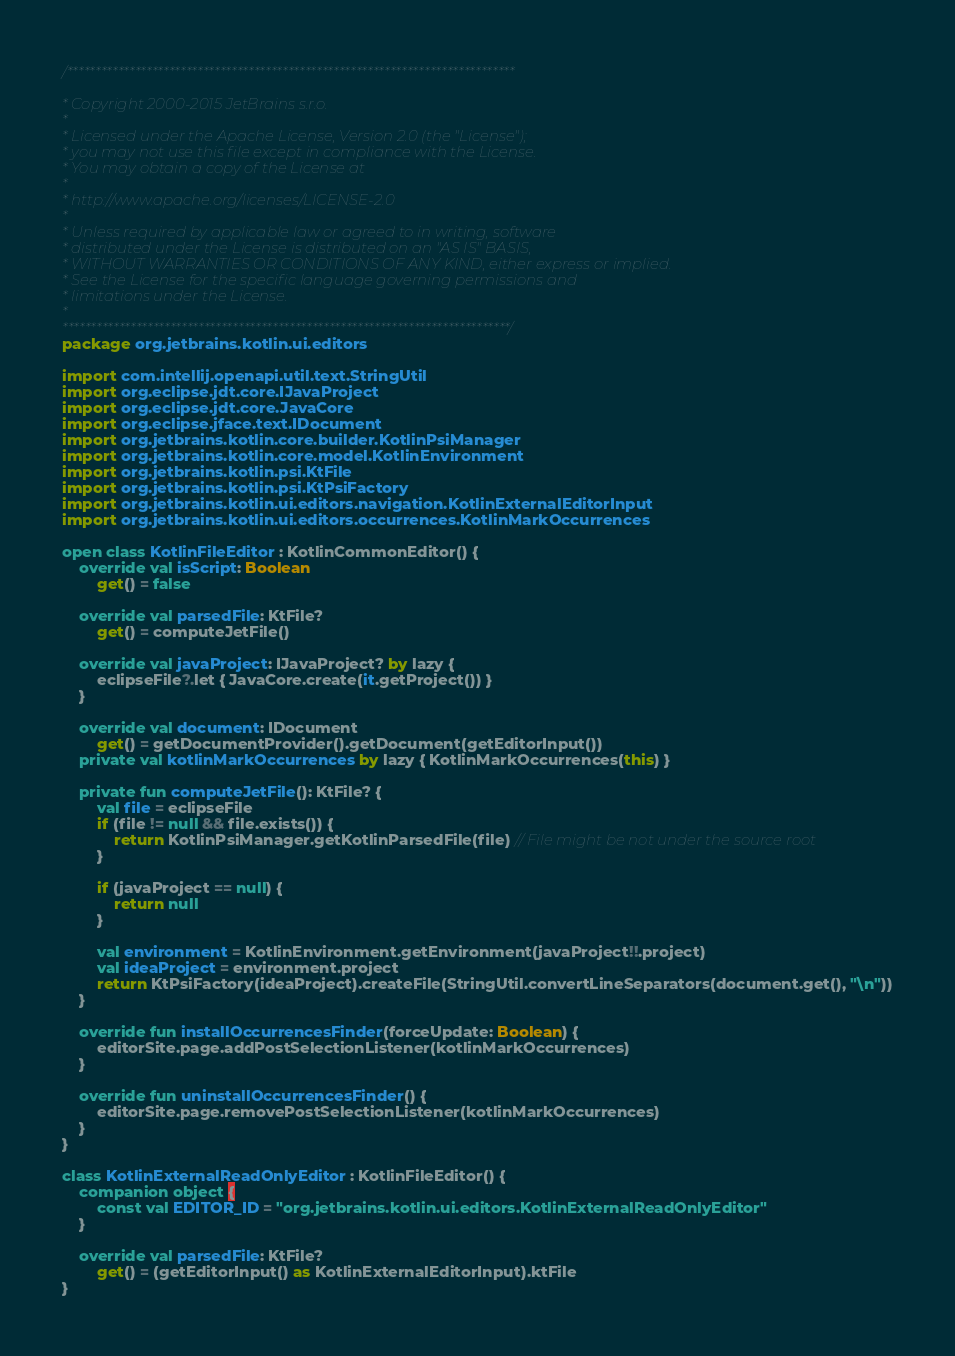Convert code to text. <code><loc_0><loc_0><loc_500><loc_500><_Kotlin_>/*******************************************************************************

* Copyright 2000-2015 JetBrains s.r.o.
*
* Licensed under the Apache License, Version 2.0 (the "License");
* you may not use this file except in compliance with the License.
* You may obtain a copy of the License at
*
* http://www.apache.org/licenses/LICENSE-2.0
*
* Unless required by applicable law or agreed to in writing, software
* distributed under the License is distributed on an "AS IS" BASIS,
* WITHOUT WARRANTIES OR CONDITIONS OF ANY KIND, either express or implied.
* See the License for the specific language governing permissions and
* limitations under the License.
*
*******************************************************************************/
package org.jetbrains.kotlin.ui.editors

import com.intellij.openapi.util.text.StringUtil
import org.eclipse.jdt.core.IJavaProject
import org.eclipse.jdt.core.JavaCore
import org.eclipse.jface.text.IDocument
import org.jetbrains.kotlin.core.builder.KotlinPsiManager
import org.jetbrains.kotlin.core.model.KotlinEnvironment
import org.jetbrains.kotlin.psi.KtFile
import org.jetbrains.kotlin.psi.KtPsiFactory
import org.jetbrains.kotlin.ui.editors.navigation.KotlinExternalEditorInput
import org.jetbrains.kotlin.ui.editors.occurrences.KotlinMarkOccurrences

open class KotlinFileEditor : KotlinCommonEditor() {
    override val isScript: Boolean
        get() = false
    
    override val parsedFile: KtFile?
        get() = computeJetFile()
    
    override val javaProject: IJavaProject? by lazy {
        eclipseFile?.let { JavaCore.create(it.getProject()) }
    }
    
    override val document: IDocument
        get() = getDocumentProvider().getDocument(getEditorInput())
    private val kotlinMarkOccurrences by lazy { KotlinMarkOccurrences(this) }

    private fun computeJetFile(): KtFile? {
        val file = eclipseFile
        if (file != null && file.exists()) {
            return KotlinPsiManager.getKotlinParsedFile(file) // File might be not under the source root
        }
        
        if (javaProject == null) {
            return null
        }
        
        val environment = KotlinEnvironment.getEnvironment(javaProject!!.project)
        val ideaProject = environment.project
        return KtPsiFactory(ideaProject).createFile(StringUtil.convertLineSeparators(document.get(), "\n"))
    }

    override fun installOccurrencesFinder(forceUpdate: Boolean) {
        editorSite.page.addPostSelectionListener(kotlinMarkOccurrences)
    }

    override fun uninstallOccurrencesFinder() {
        editorSite.page.removePostSelectionListener(kotlinMarkOccurrences)
    }
}

class KotlinExternalReadOnlyEditor : KotlinFileEditor() {
    companion object {
        const val EDITOR_ID = "org.jetbrains.kotlin.ui.editors.KotlinExternalReadOnlyEditor"
    }
    
    override val parsedFile: KtFile?
        get() = (getEditorInput() as KotlinExternalEditorInput).ktFile
}</code> 